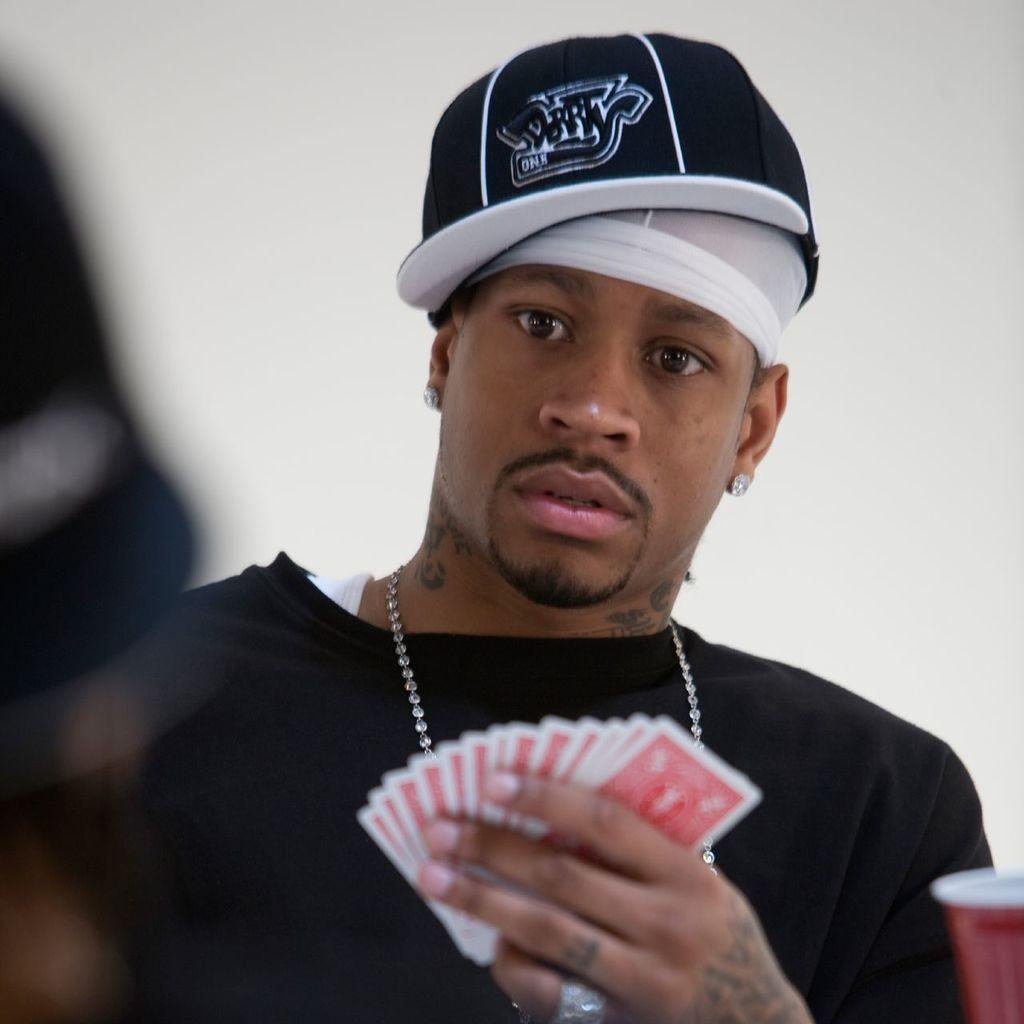What is the main subject of the image? There is a person in the image. What is the person wearing on their upper body? The person is wearing a black T-shirt. What type of headwear is the person wearing? The person is wearing a cap. What is the person holding in their hands? The person is holding cards in their hands. What can be seen in the background of the image? There is a wall in the background of the image. What type of collar is visible on the person's shirt in the image? The person is wearing a T-shirt, which typically does not have a collar. 